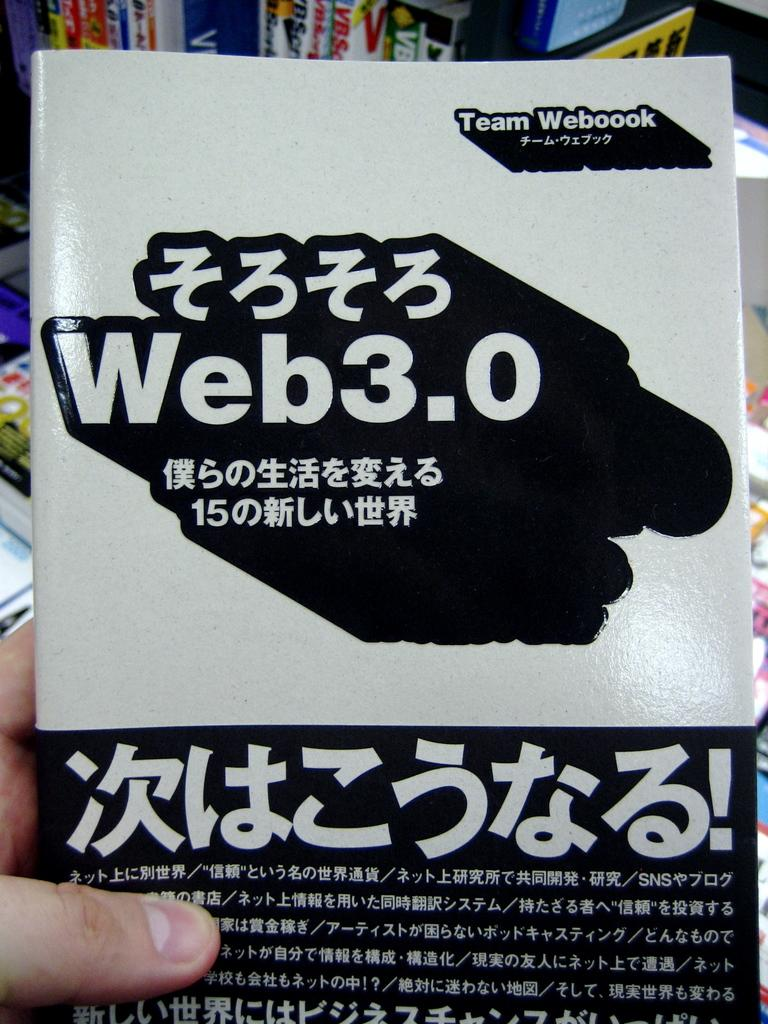Provide a one-sentence caption for the provided image. a japanese language web 3.0 instruction booklet by team webbook. 